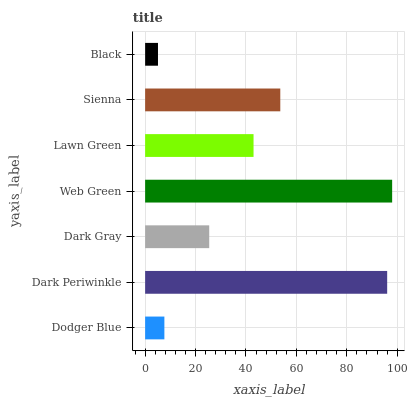Is Black the minimum?
Answer yes or no. Yes. Is Web Green the maximum?
Answer yes or no. Yes. Is Dark Periwinkle the minimum?
Answer yes or no. No. Is Dark Periwinkle the maximum?
Answer yes or no. No. Is Dark Periwinkle greater than Dodger Blue?
Answer yes or no. Yes. Is Dodger Blue less than Dark Periwinkle?
Answer yes or no. Yes. Is Dodger Blue greater than Dark Periwinkle?
Answer yes or no. No. Is Dark Periwinkle less than Dodger Blue?
Answer yes or no. No. Is Lawn Green the high median?
Answer yes or no. Yes. Is Lawn Green the low median?
Answer yes or no. Yes. Is Dark Gray the high median?
Answer yes or no. No. Is Dark Periwinkle the low median?
Answer yes or no. No. 